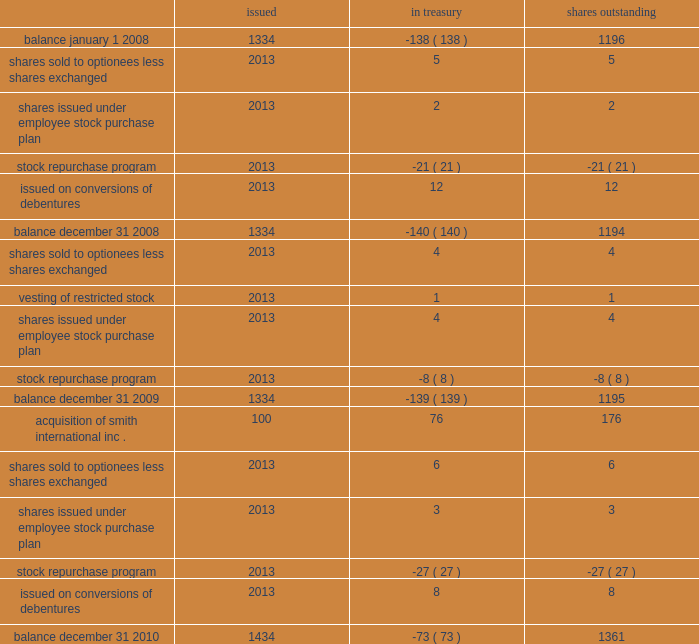Schlumberger limited and subsidiaries shares of common stock issued in treasury shares outstanding ( stated in millions ) .
See the notes to consolidated financial statements part ii , item 8 .
What was the average beginning and ending balance of shares in millions outstanding during 2010? 
Computations: ((1361 + 1195) / 2)
Answer: 1278.0. 